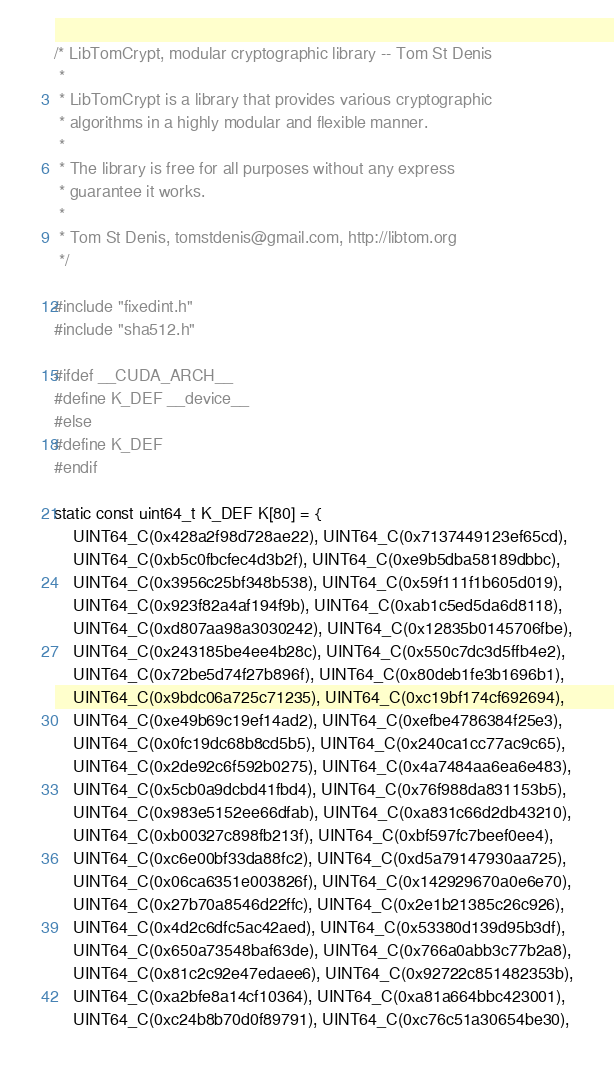<code> <loc_0><loc_0><loc_500><loc_500><_Cuda_>/* LibTomCrypt, modular cryptographic library -- Tom St Denis
 *
 * LibTomCrypt is a library that provides various cryptographic
 * algorithms in a highly modular and flexible manner.
 *
 * The library is free for all purposes without any express
 * guarantee it works.
 *
 * Tom St Denis, tomstdenis@gmail.com, http://libtom.org
 */

#include "fixedint.h"
#include "sha512.h"

#ifdef __CUDA_ARCH__
#define K_DEF __device__
#else
#define K_DEF
#endif

static const uint64_t K_DEF K[80] = {
    UINT64_C(0x428a2f98d728ae22), UINT64_C(0x7137449123ef65cd),
    UINT64_C(0xb5c0fbcfec4d3b2f), UINT64_C(0xe9b5dba58189dbbc),
    UINT64_C(0x3956c25bf348b538), UINT64_C(0x59f111f1b605d019),
    UINT64_C(0x923f82a4af194f9b), UINT64_C(0xab1c5ed5da6d8118),
    UINT64_C(0xd807aa98a3030242), UINT64_C(0x12835b0145706fbe),
    UINT64_C(0x243185be4ee4b28c), UINT64_C(0x550c7dc3d5ffb4e2),
    UINT64_C(0x72be5d74f27b896f), UINT64_C(0x80deb1fe3b1696b1),
    UINT64_C(0x9bdc06a725c71235), UINT64_C(0xc19bf174cf692694),
    UINT64_C(0xe49b69c19ef14ad2), UINT64_C(0xefbe4786384f25e3),
    UINT64_C(0x0fc19dc68b8cd5b5), UINT64_C(0x240ca1cc77ac9c65),
    UINT64_C(0x2de92c6f592b0275), UINT64_C(0x4a7484aa6ea6e483),
    UINT64_C(0x5cb0a9dcbd41fbd4), UINT64_C(0x76f988da831153b5),
    UINT64_C(0x983e5152ee66dfab), UINT64_C(0xa831c66d2db43210),
    UINT64_C(0xb00327c898fb213f), UINT64_C(0xbf597fc7beef0ee4),
    UINT64_C(0xc6e00bf33da88fc2), UINT64_C(0xd5a79147930aa725),
    UINT64_C(0x06ca6351e003826f), UINT64_C(0x142929670a0e6e70),
    UINT64_C(0x27b70a8546d22ffc), UINT64_C(0x2e1b21385c26c926),
    UINT64_C(0x4d2c6dfc5ac42aed), UINT64_C(0x53380d139d95b3df),
    UINT64_C(0x650a73548baf63de), UINT64_C(0x766a0abb3c77b2a8),
    UINT64_C(0x81c2c92e47edaee6), UINT64_C(0x92722c851482353b),
    UINT64_C(0xa2bfe8a14cf10364), UINT64_C(0xa81a664bbc423001),
    UINT64_C(0xc24b8b70d0f89791), UINT64_C(0xc76c51a30654be30),</code> 